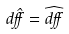Convert formula to latex. <formula><loc_0><loc_0><loc_500><loc_500>d \hat { \alpha } = \widehat { d \alpha }</formula> 